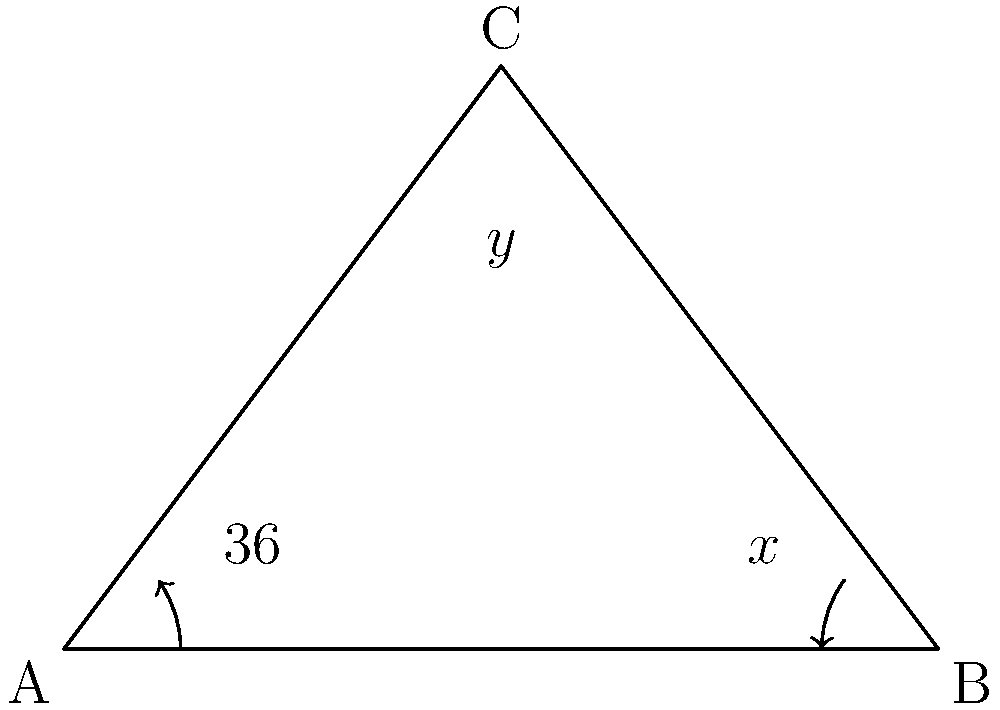A historic property features a uniquely shaped bay window in the form of an isosceles triangle. The base angles of this triangle are known to be $36°$ each. Calculate the measure of angle $y$ at the apex of the triangle. To find the measure of angle $y$ at the apex of the isosceles triangle, we can follow these steps:

1) In any triangle, the sum of all interior angles is always $180°$. This is a fundamental property of triangles.

2) We are given that the two base angles are equal and measure $36°$ each. Let's call these angles $x$.

3) We can set up an equation based on the fact that the sum of all angles in a triangle is $180°$:

   $x + x + y = 180°$

4) Substituting the known value for $x$:

   $36° + 36° + y = 180°$

5) Simplify:

   $72° + y = 180°$

6) Subtract $72°$ from both sides:

   $y = 180° - 72°$

7) Calculate:

   $y = 108°$

Therefore, the measure of angle $y$ at the apex of the isosceles triangle is $108°$.
Answer: $108°$ 